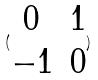Convert formula to latex. <formula><loc_0><loc_0><loc_500><loc_500>( \begin{matrix} 0 & 1 \\ - 1 & 0 \\ \end{matrix} )</formula> 